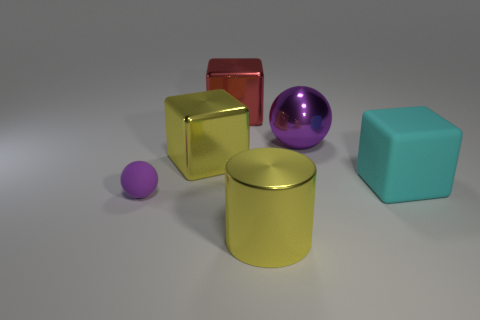There is a big metallic sphere; does it have the same color as the rubber object left of the large yellow cylinder?
Keep it short and to the point. Yes. What number of balls are the same color as the small matte thing?
Provide a short and direct response. 1. There is a purple shiny ball; how many cyan rubber cubes are in front of it?
Provide a succinct answer. 1. How many things are cyan shiny balls or yellow cylinders?
Your answer should be compact. 1. The object that is left of the red block and on the right side of the tiny purple rubber object has what shape?
Your answer should be compact. Cube. What number of big blue rubber balls are there?
Ensure brevity in your answer.  0. There is a large object that is made of the same material as the small purple sphere; what is its color?
Offer a very short reply. Cyan. Is the number of large purple metal spheres greater than the number of purple cylinders?
Offer a very short reply. Yes. There is a object that is on the left side of the yellow cylinder and in front of the cyan thing; how big is it?
Offer a terse response. Small. What is the material of the thing that is the same color as the big shiny ball?
Your answer should be compact. Rubber. 